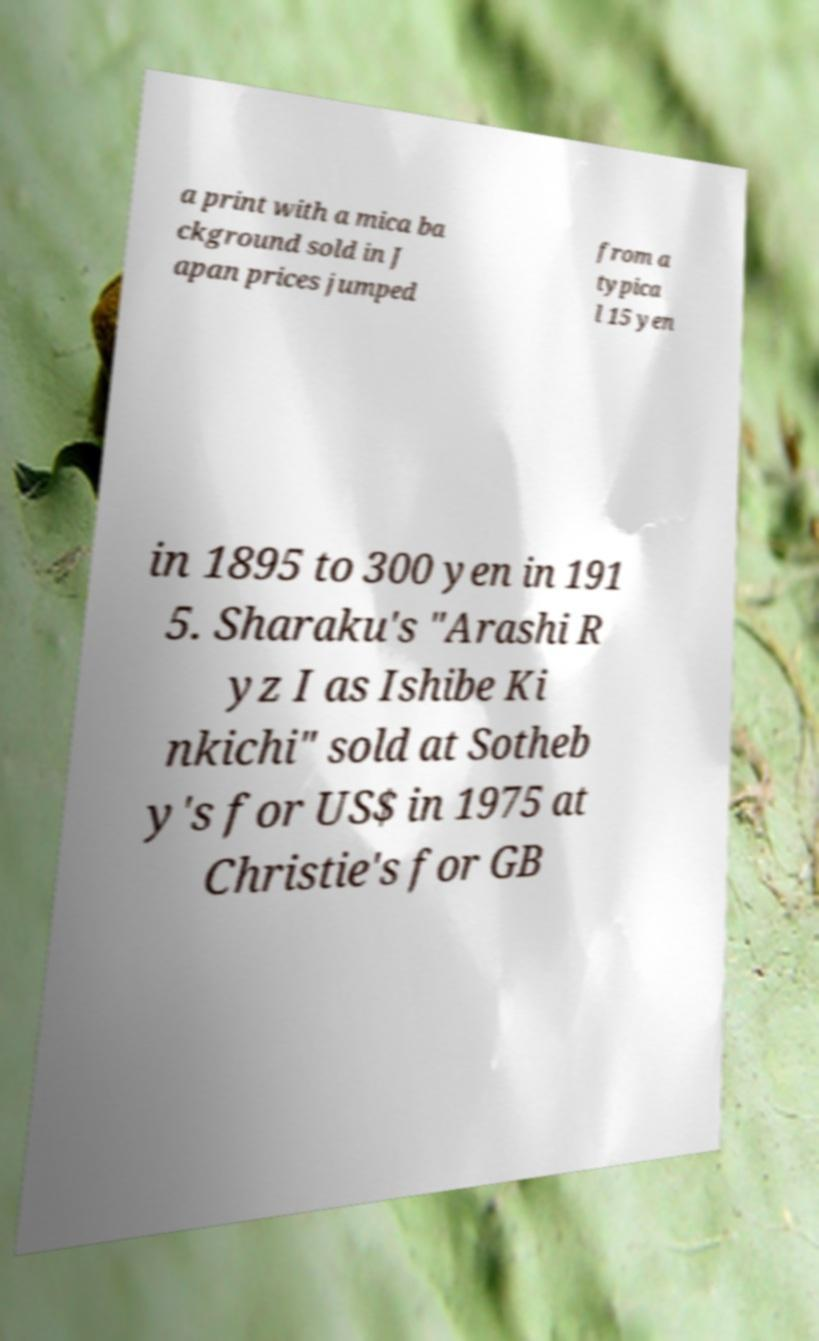Can you accurately transcribe the text from the provided image for me? a print with a mica ba ckground sold in J apan prices jumped from a typica l 15 yen in 1895 to 300 yen in 191 5. Sharaku's "Arashi R yz I as Ishibe Ki nkichi" sold at Sotheb y's for US$ in 1975 at Christie's for GB 